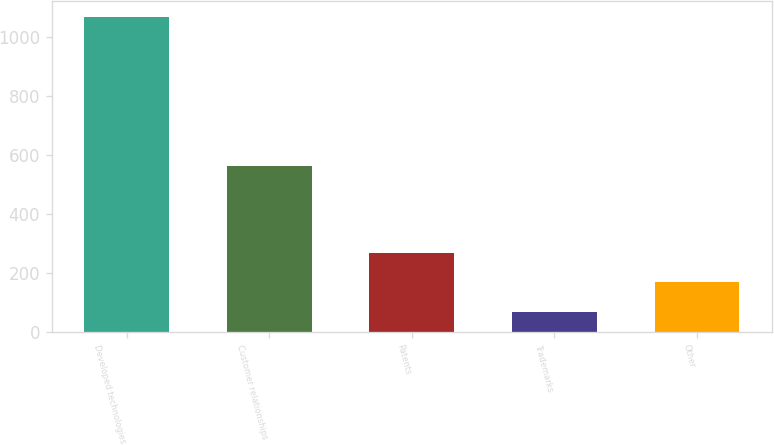Convert chart. <chart><loc_0><loc_0><loc_500><loc_500><bar_chart><fcel>Developed technologies<fcel>Customer relationships<fcel>Patents<fcel>Trademarks<fcel>Other<nl><fcel>1069<fcel>563<fcel>269<fcel>69<fcel>169<nl></chart> 